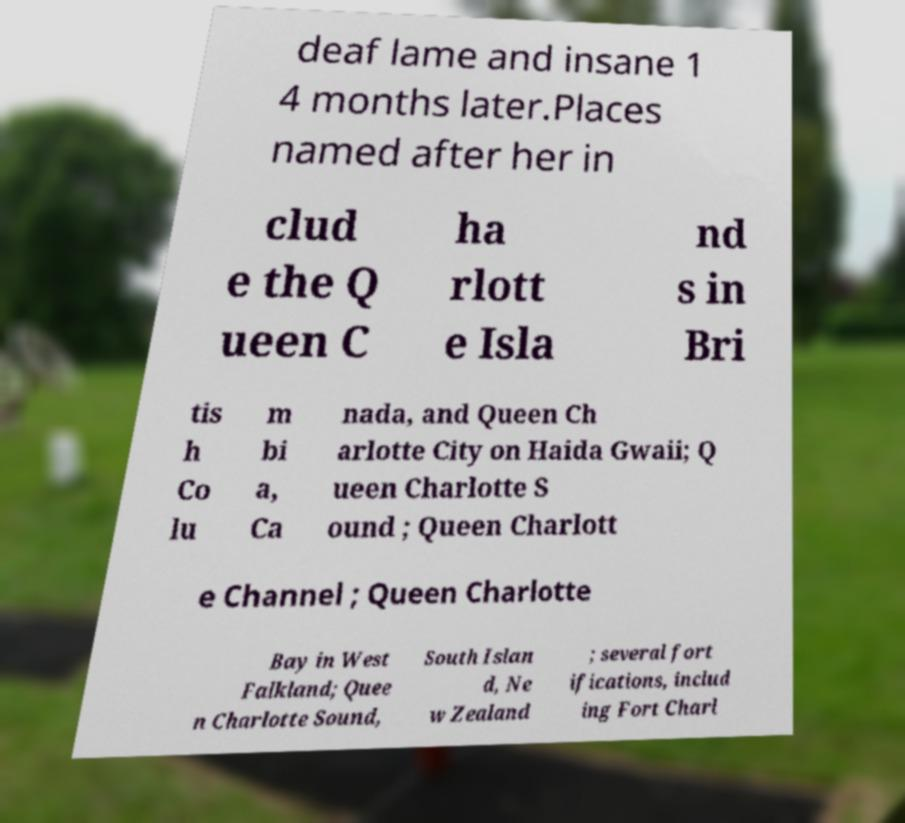What messages or text are displayed in this image? I need them in a readable, typed format. deaf lame and insane 1 4 months later.Places named after her in clud e the Q ueen C ha rlott e Isla nd s in Bri tis h Co lu m bi a, Ca nada, and Queen Ch arlotte City on Haida Gwaii; Q ueen Charlotte S ound ; Queen Charlott e Channel ; Queen Charlotte Bay in West Falkland; Quee n Charlotte Sound, South Islan d, Ne w Zealand ; several fort ifications, includ ing Fort Charl 